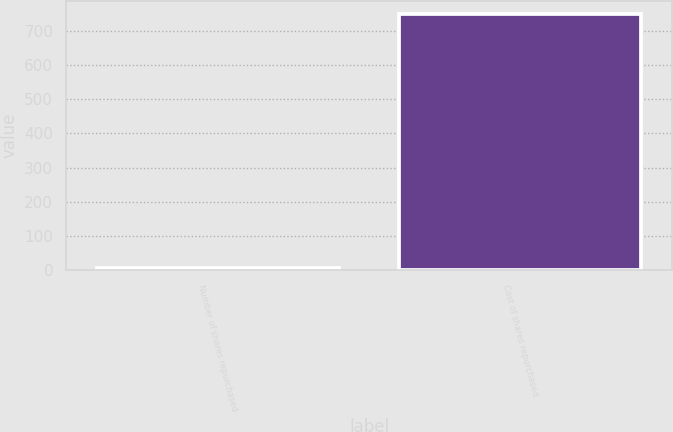Convert chart. <chart><loc_0><loc_0><loc_500><loc_500><bar_chart><fcel>Number of shares repurchased<fcel>Cost of shares repurchased<nl><fcel>7.6<fcel>750<nl></chart> 